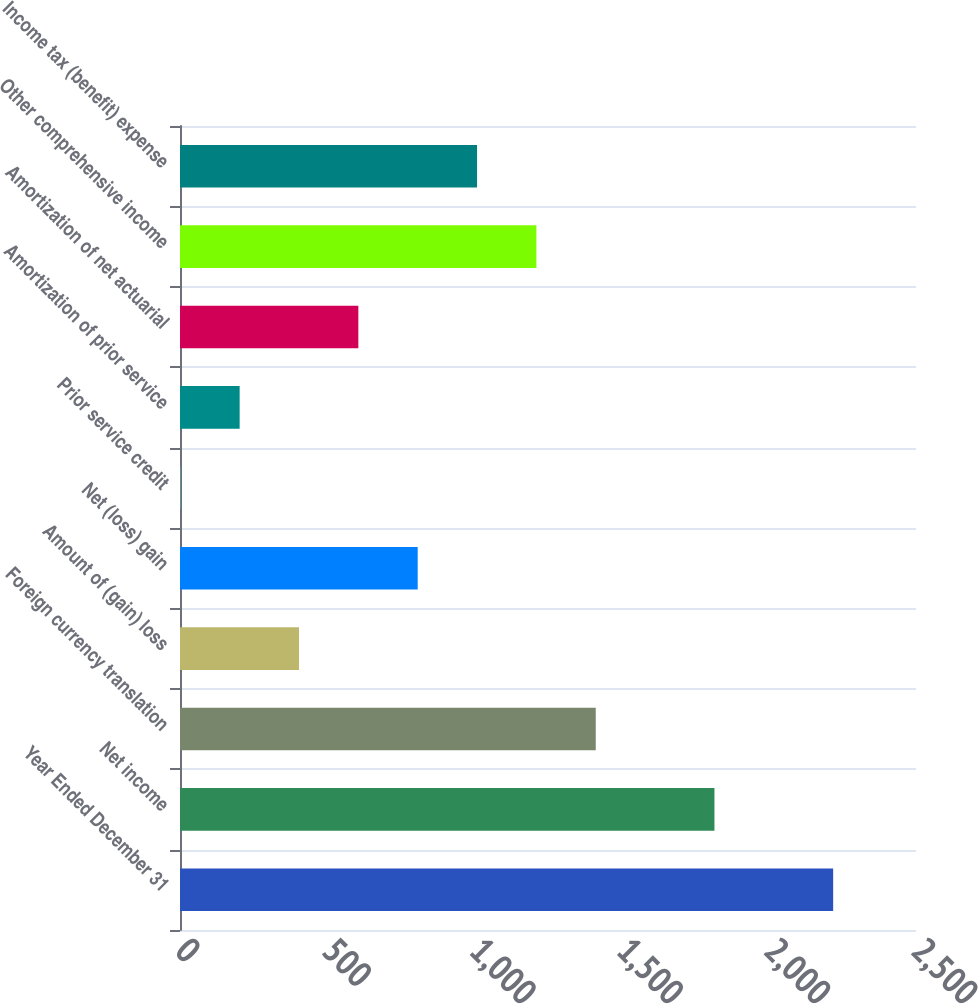<chart> <loc_0><loc_0><loc_500><loc_500><bar_chart><fcel>Year Ended December 31<fcel>Net income<fcel>Foreign currency translation<fcel>Amount of (gain) loss<fcel>Net (loss) gain<fcel>Prior service credit<fcel>Amortization of prior service<fcel>Amortization of net actuarial<fcel>Other comprehensive income<fcel>Income tax (benefit) expense<nl><fcel>2218.6<fcel>1815.4<fcel>1412.2<fcel>404.2<fcel>807.4<fcel>1<fcel>202.6<fcel>605.8<fcel>1210.6<fcel>1009<nl></chart> 